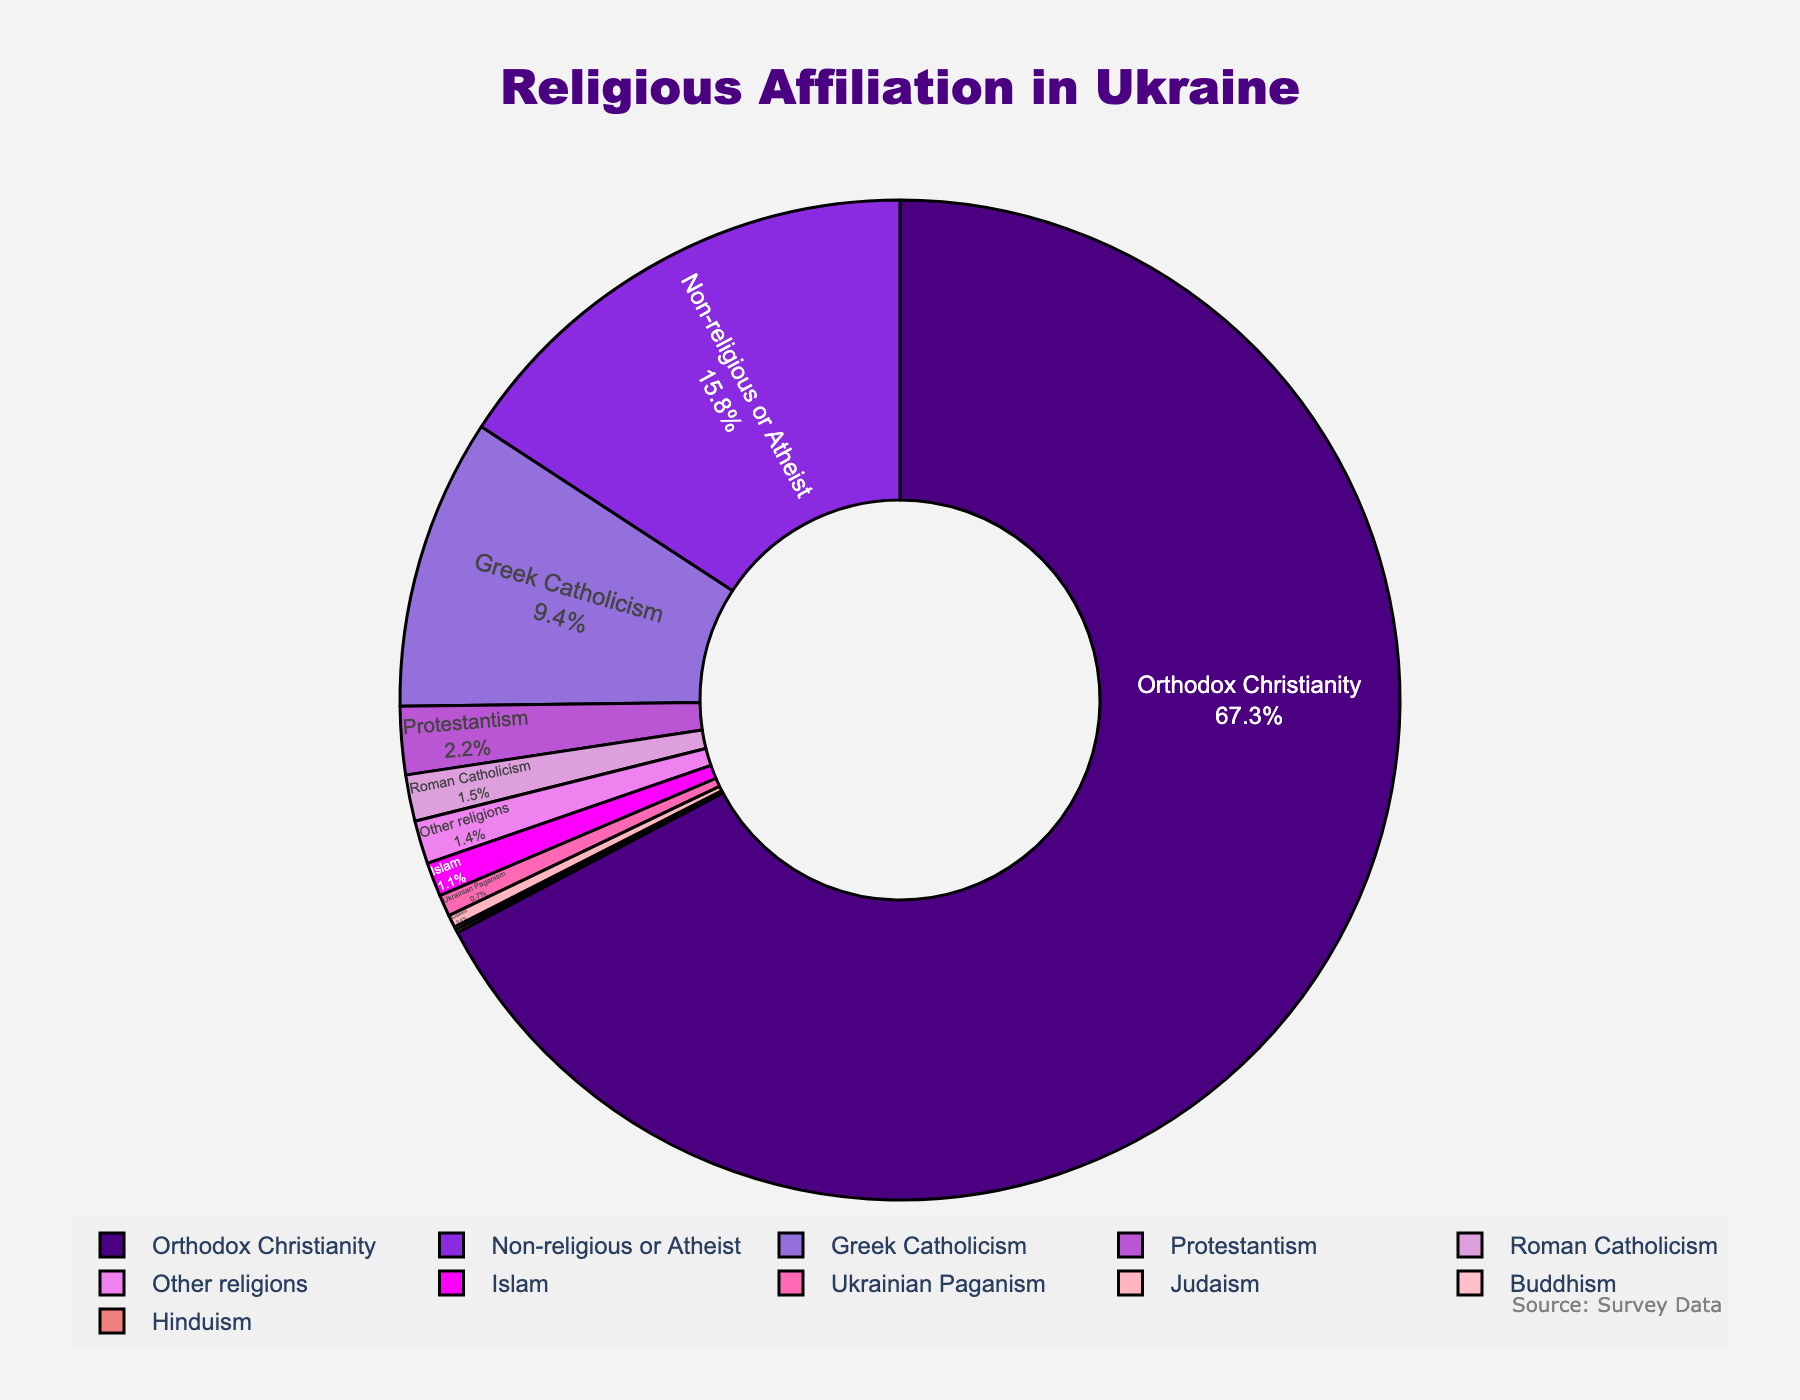What is the most common religious affiliation in Ukraine? The largest segment in the pie chart represents Orthodox Christianity, which has the highest percentage among all religious affiliations.
Answer: Orthodox Christianity What is the combined percentage of those identifying as Greek Catholic and Roman Catholic? According to the pie chart, Greek Catholicism accounts for 9.4% and Roman Catholicism accounts for 1.5% of the population. Adding these percentages together yields 9.4% + 1.5% = 10.9%.
Answer: 10.9% Which religion has a smaller proportion, Judaism or Islam? Judaism is represented by a smaller segment compared to Islam in the pie chart. Judaism accounts for 0.4% while Islam accounts for 1.1%. Therefore, Judaism has a smaller proportion.
Answer: Judaism What is the percentage difference between Orthodox Christianity and Non-religious or Atheist? Orthodox Christianity has a percentage of 67.3% and Non-religious or Atheist has 15.8%. The difference between these two percentages is 67.3% - 15.8% = 51.5%.
Answer: 51.5% What percentage of the population is affiliated with religions other than Orthodox Christianity, Greek Catholicism, and Roman Catholicism combined? The combined percentage for Orthodox Christianity, Greek Catholicism, and Roman Catholicism is 67.3% + 9.4% + 1.5% = 78.2%. Therefore, the percentage of the population affiliated with other religions is 100% - 78.2% = 21.8%.
Answer: 21.8% How does the proportion of Protestantism compare to that of Other religions? Protestantism has a percentage of 2.2% and Other religions have a percentage of 1.4%. By comparing the two, Protestantism is greater at 2.2% compared to Other religions at 1.4%.
Answer: Protestantism is greater What color represents Greek Catholicism in the pie chart? Visually inspecting the pie chart, Greek Catholicism is marked with the color second from the top, which appears as a bold purple (light purple) to distinguish it.
Answer: Bold purple (light purple) What is the sum of the percentages for Hinduism and Buddhism? According to the pie chart, Hinduism accounts for 0.1% and Buddhism also accounts for 0.1%. Adding these percentages together yields 0.1% + 0.1% = 0.2%.
Answer: 0.2% How many religious groups have a percentage less than 1%? From the pie chart, the religions with less than 1% are Roman Catholicism (1.5% should be ignored), Islam, Judaism, Ukrainian Paganism, Buddhism, and Hinduism. Counting these groups provides a total of 5 religious groups.
Answer: 5 